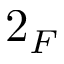Convert formula to latex. <formula><loc_0><loc_0><loc_500><loc_500>2 _ { F }</formula> 